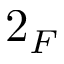Convert formula to latex. <formula><loc_0><loc_0><loc_500><loc_500>2 _ { F }</formula> 